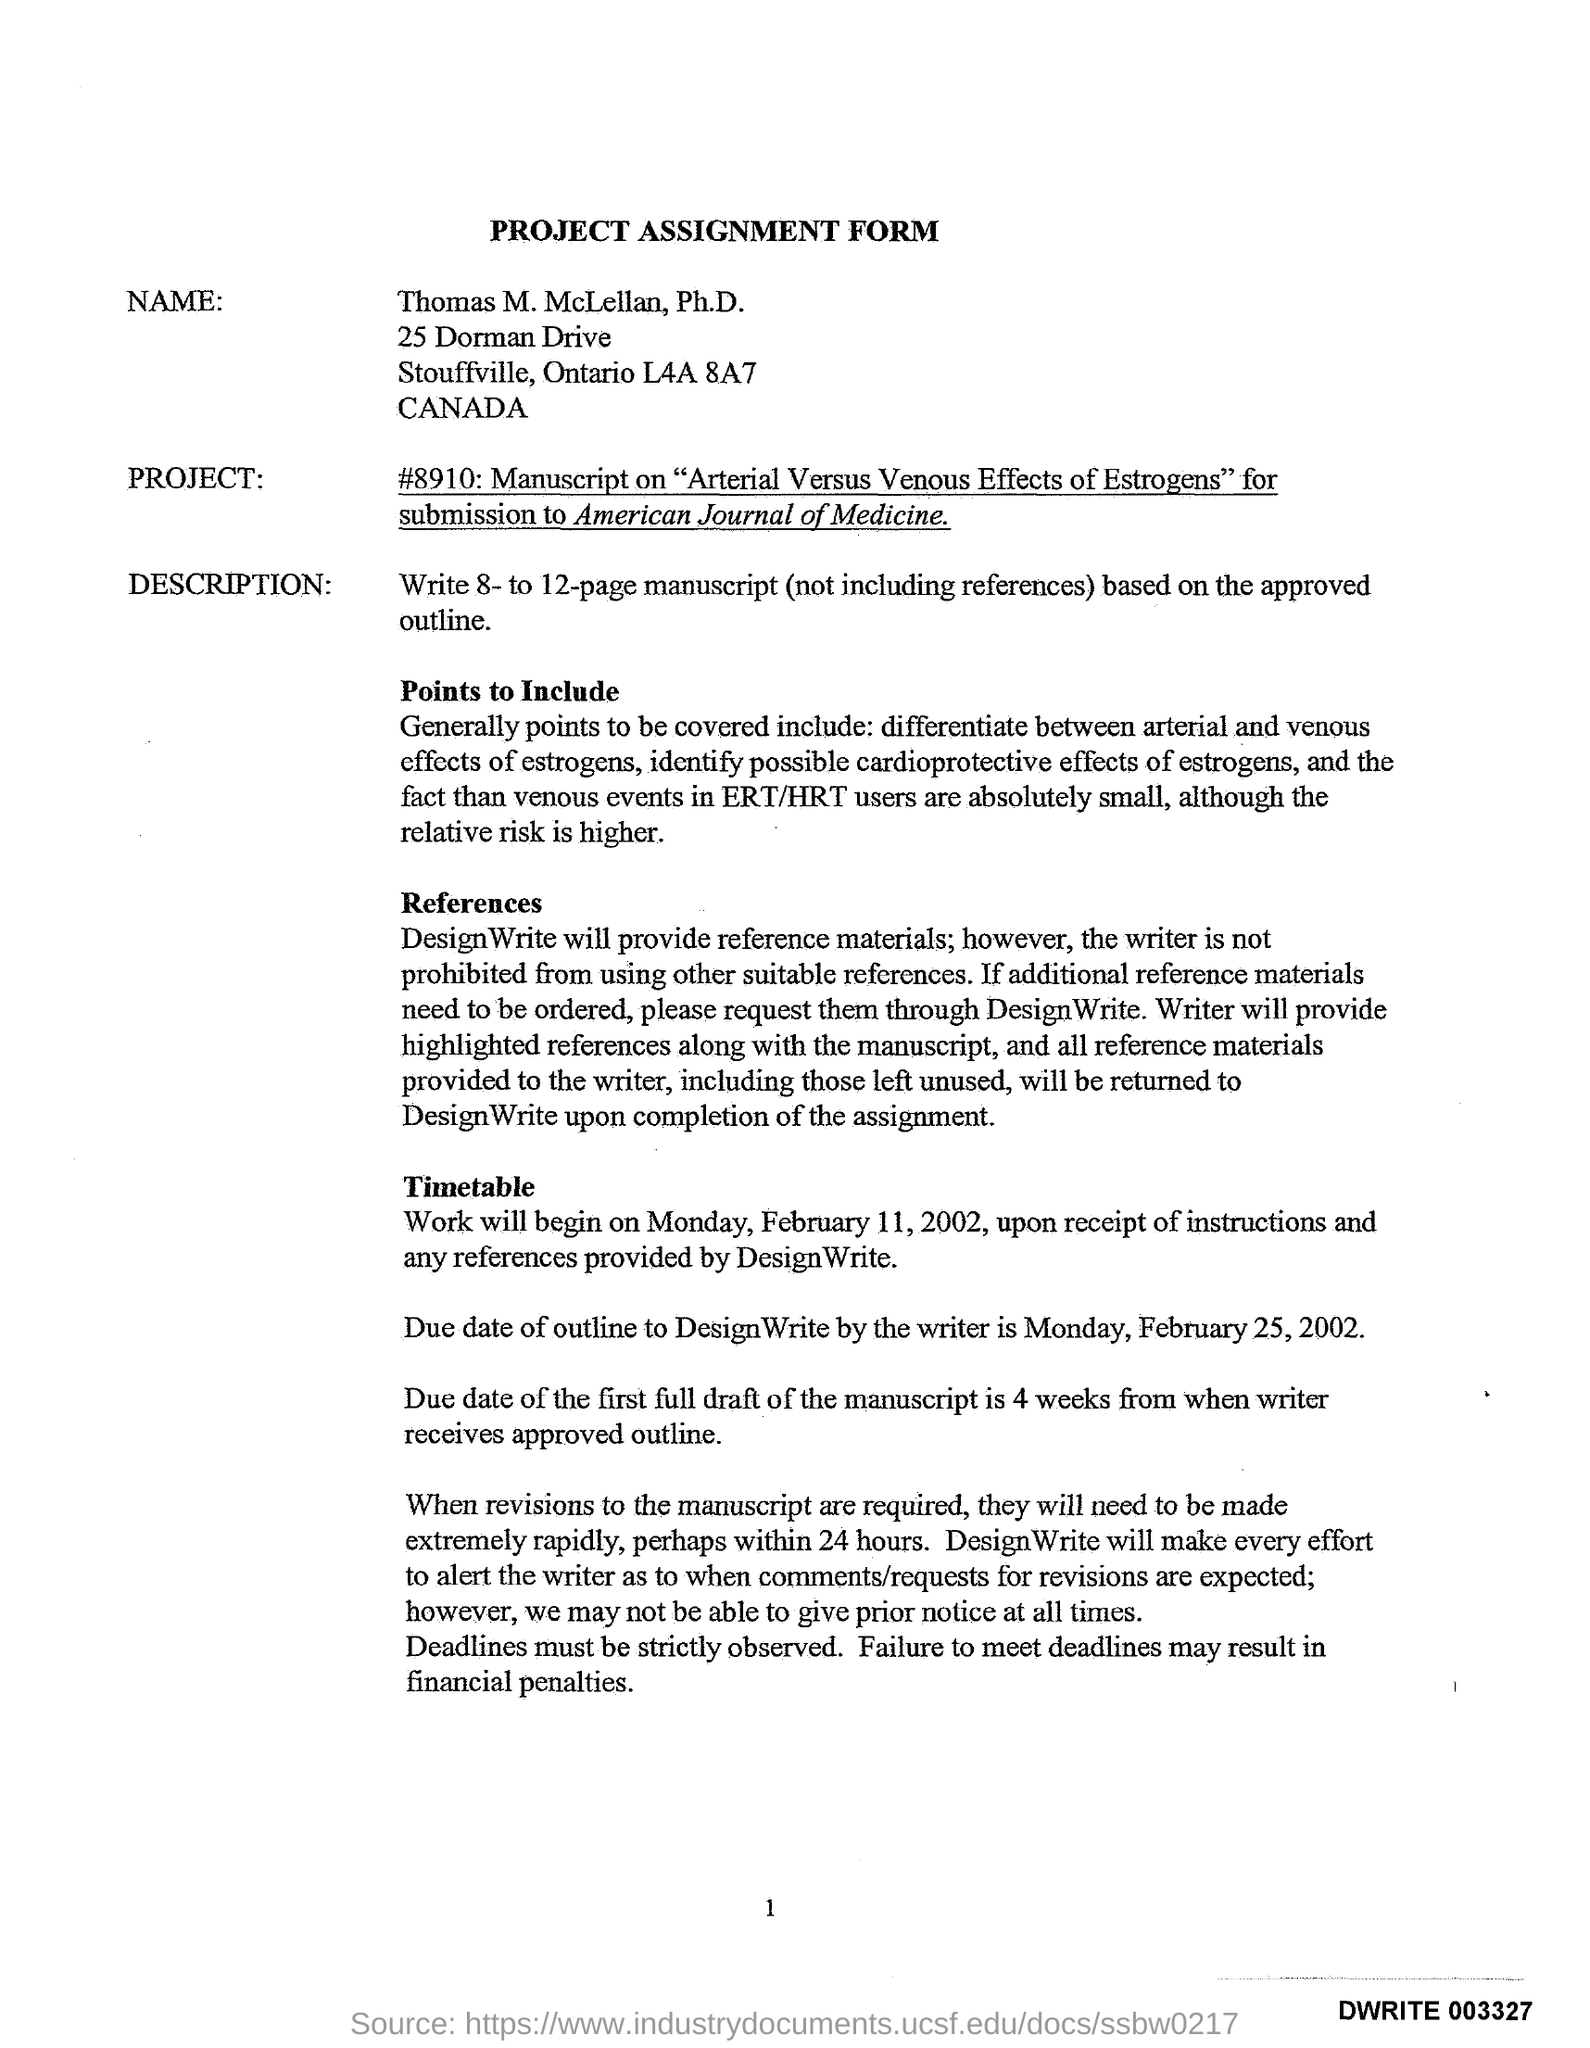Indicate a few pertinent items in this graphic. The project was started on February 11, 2002. If deadlines are not met, there may be financial penalties as a result of failure to comply. The project will be submitted to the American Journal of Medicine. 